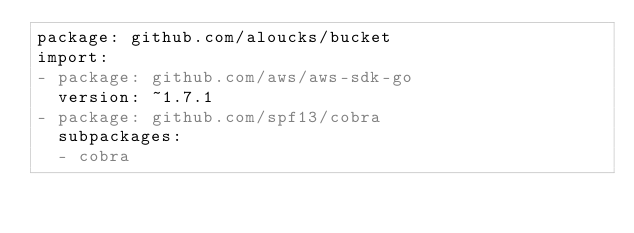<code> <loc_0><loc_0><loc_500><loc_500><_YAML_>package: github.com/aloucks/bucket
import:
- package: github.com/aws/aws-sdk-go
  version: ~1.7.1
- package: github.com/spf13/cobra
  subpackages:
  - cobra
</code> 